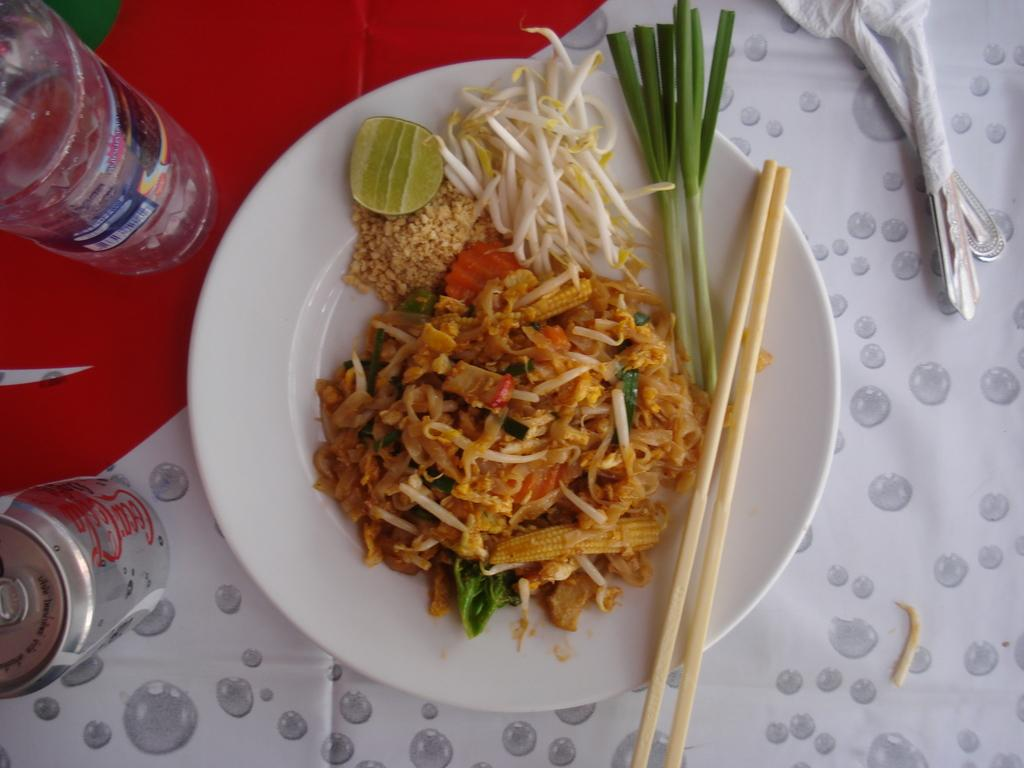What is present in the image that people typically use to eat? There are chopsticks and spoons in the image that people typically use to eat. What is the food placed on in the image? The food and chopsticks are in a plate in the image. What else can be seen in the image besides food and utensils? There is a water bottle and a can in the image. What type of plantation can be seen in the image? There is no plantation present in the image. What kind of furniture is visible in the image? There is no furniture visible in the image. 